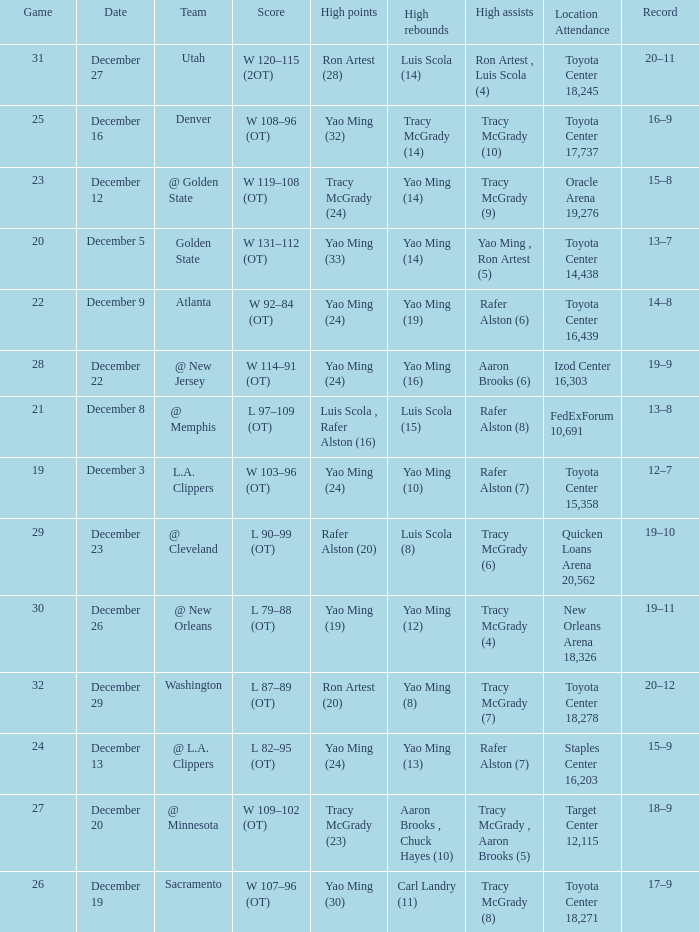When @ new orleans is the team who has the highest amount of rebounds? Yao Ming (12). 